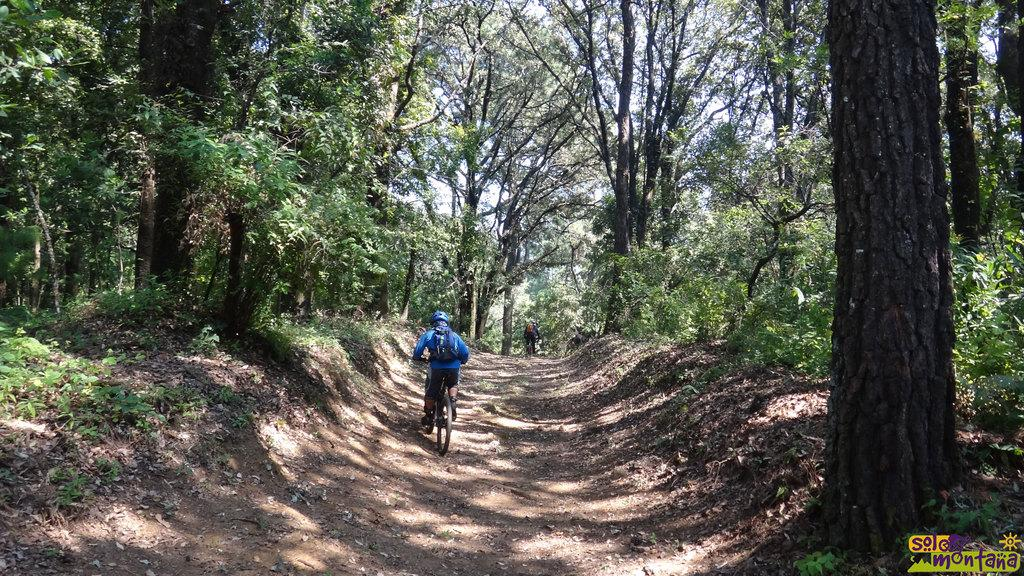How many people are in the image? There are two persons in the image. What are the persons doing in the image? The persons are riding bicycles. What can be seen in the background of the image? There are trees and the sky visible in the background of the image. What type of powder is being used by the persons in the image? There is no powder present in the image; the persons are riding bicycles. Where is the train located in the image? There is no train present in the image; the main subjects are two persons riding bicycles. 